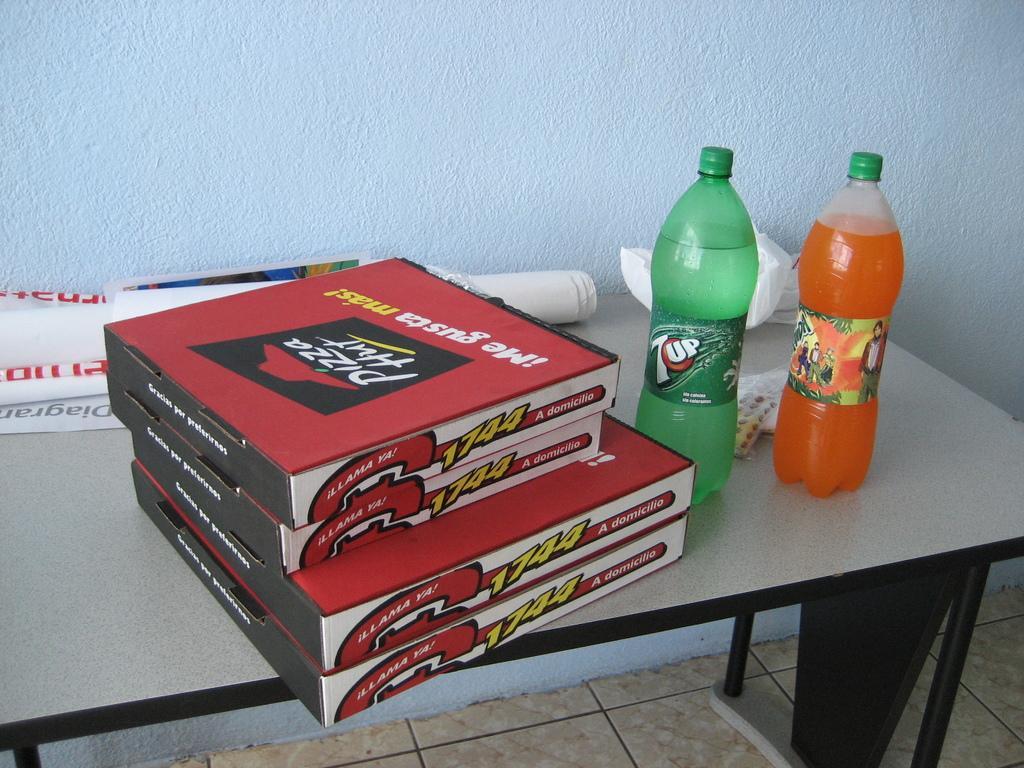Can you describe this image briefly? We can see boxes,bottles,paper,poster on the table. On the background we can see wall. This is floor. 